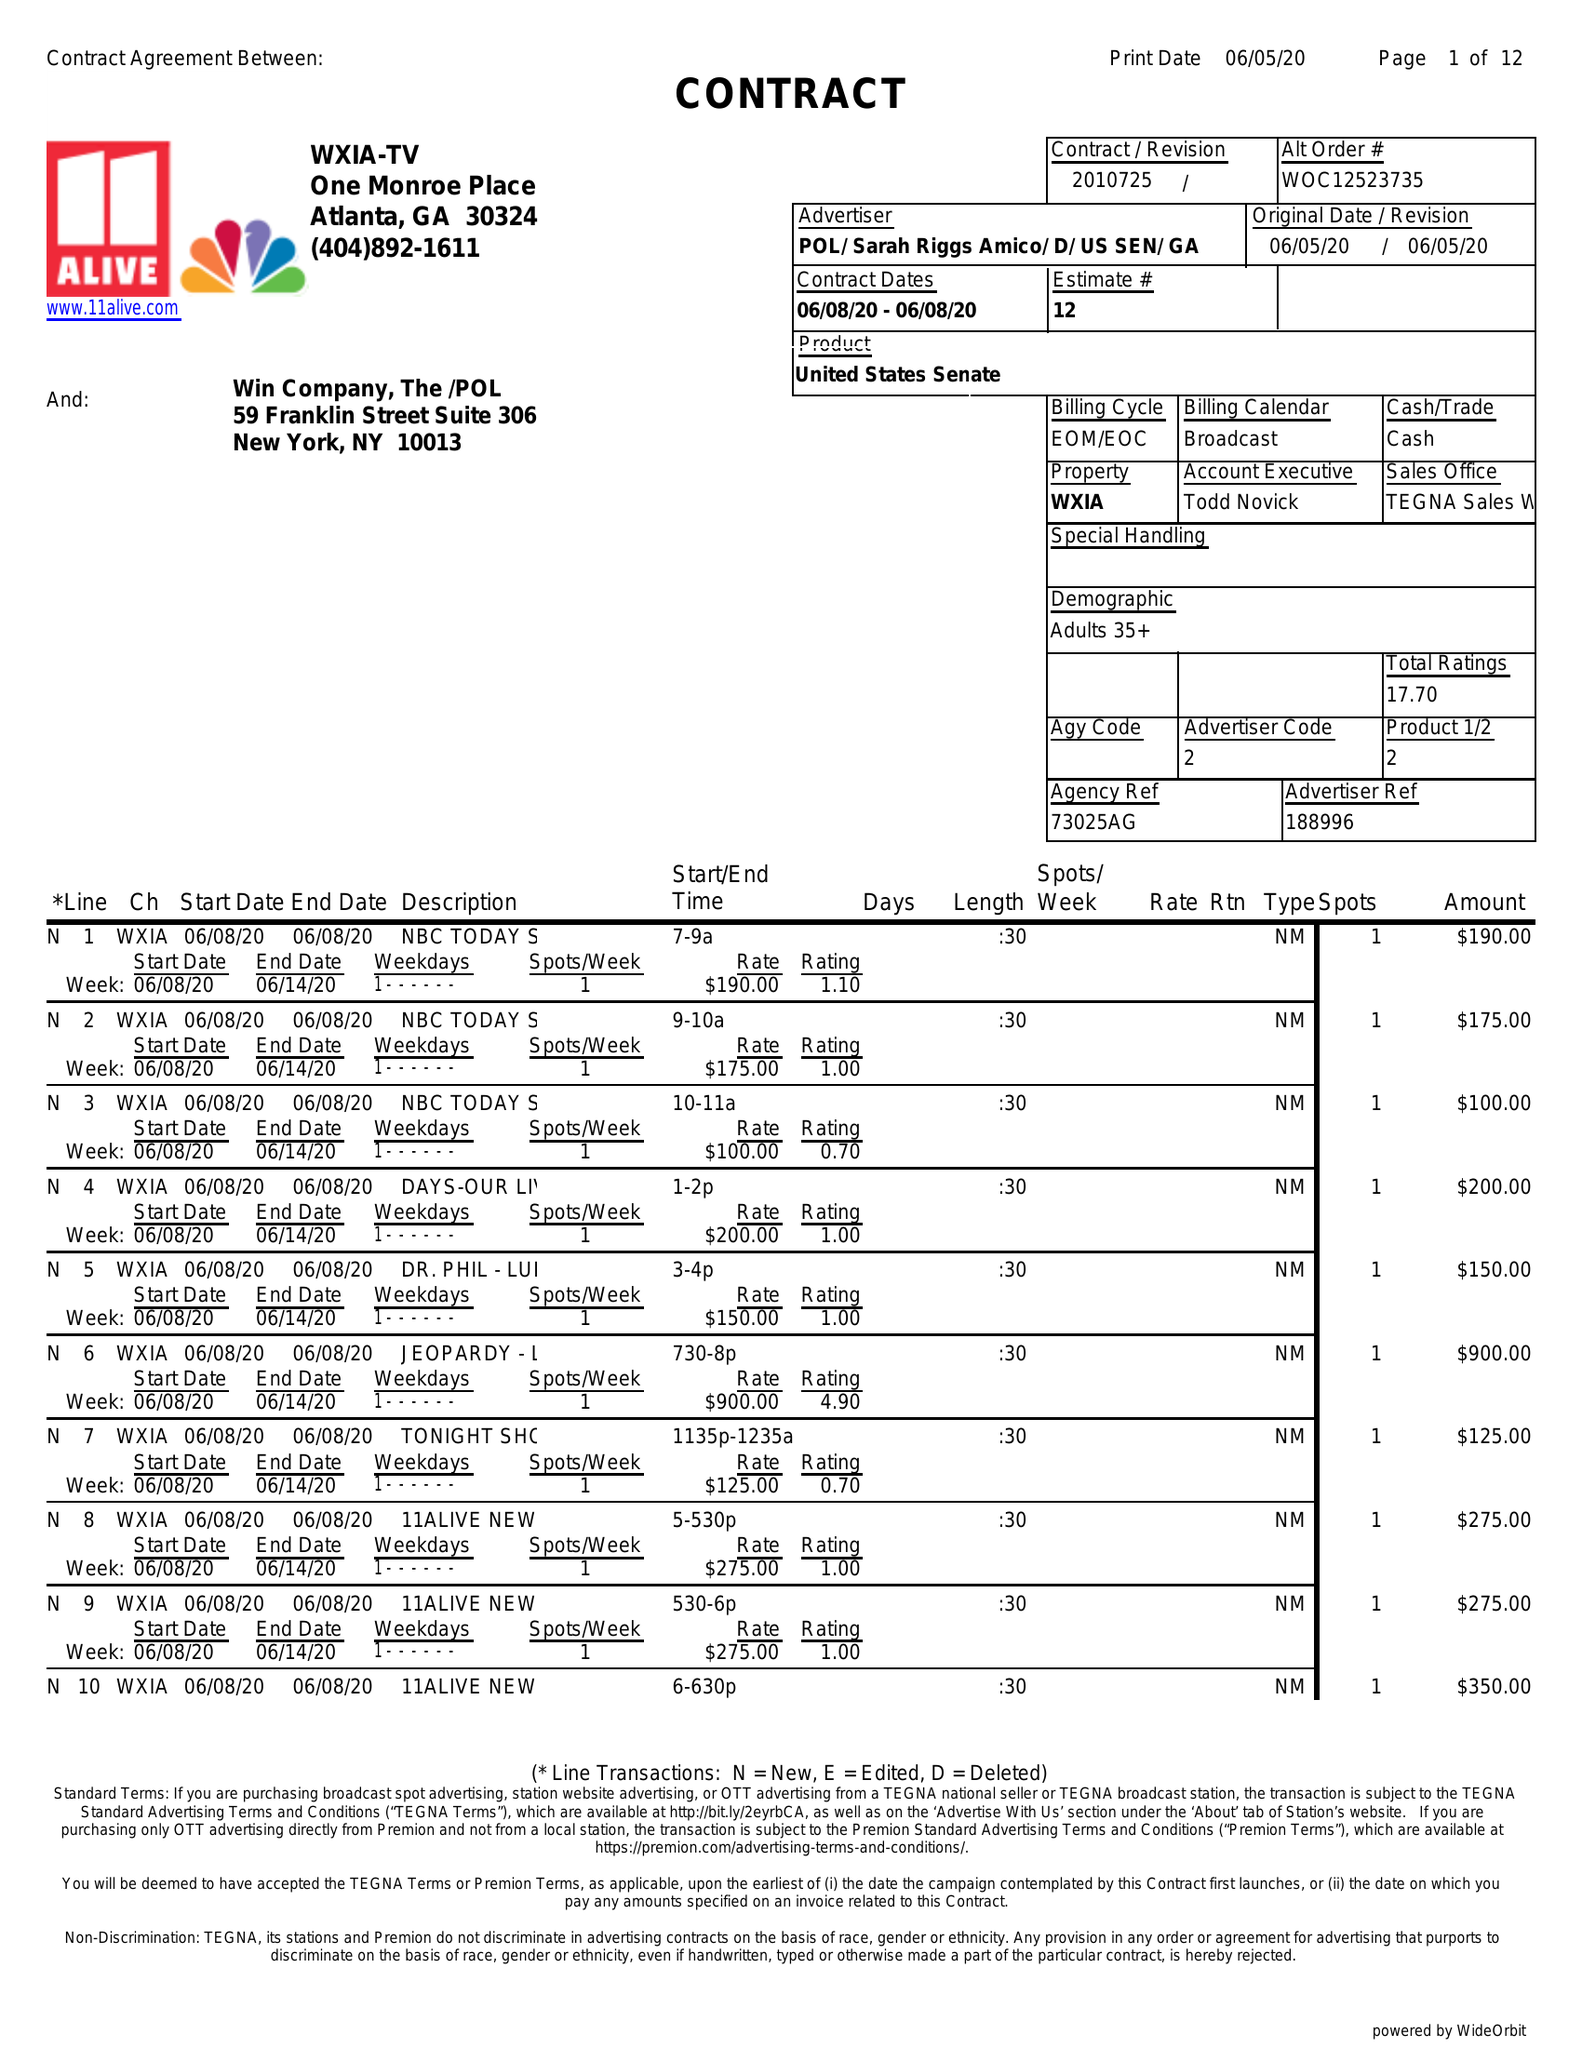What is the value for the advertiser?
Answer the question using a single word or phrase. POL/SARAHRIGGSAMICO/D/USSEN/GA 